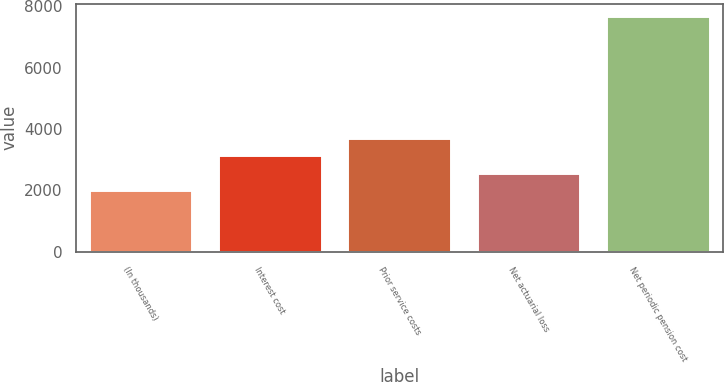Convert chart to OTSL. <chart><loc_0><loc_0><loc_500><loc_500><bar_chart><fcel>(In thousands)<fcel>Interest cost<fcel>Prior service costs<fcel>Net actuarial loss<fcel>Net periodic pension cost<nl><fcel>2012<fcel>3148.8<fcel>3717.2<fcel>2580.4<fcel>7696<nl></chart> 